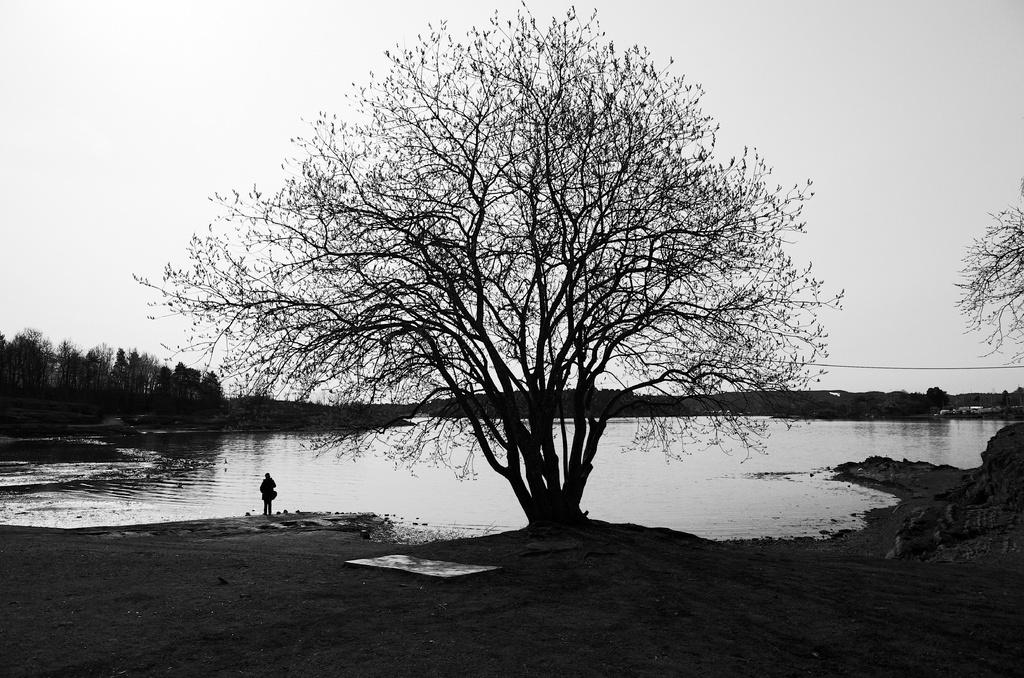What is the person in the image doing? There is a person standing on the ground in the image. What can be seen in the background of the image? There are trees and water visible in the background of the image. What else is visible in the background of the image? The sky is also visible in the background of the image. What type of pen is the person holding in the image? There is no pen present in the image; the person is simply standing on the ground. 